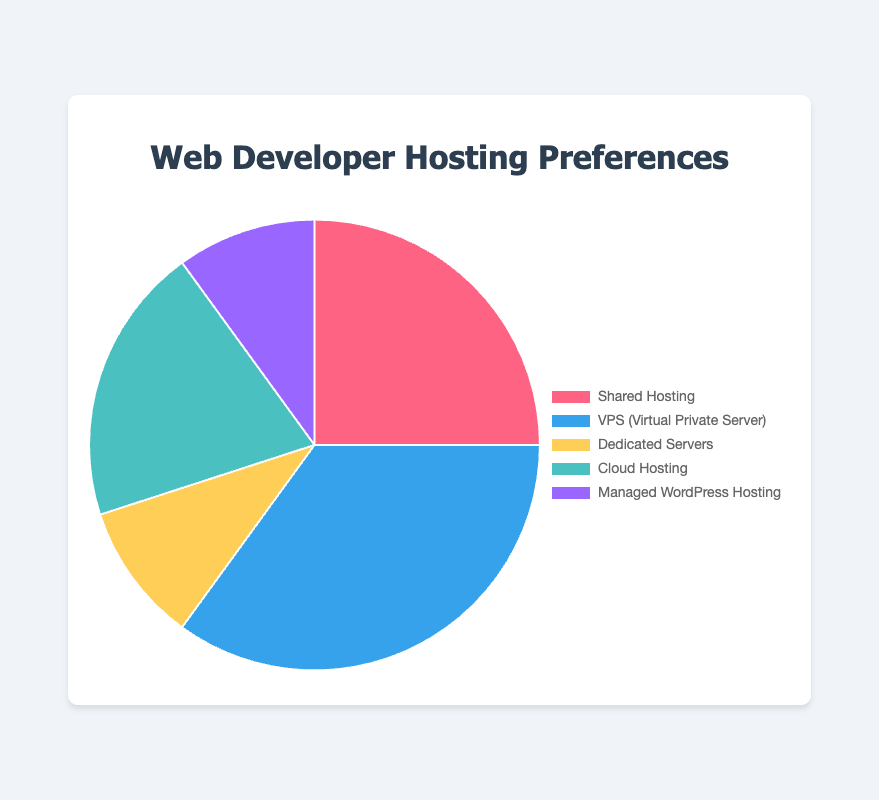Which hosting service has the highest usage percentage among web developers? To find the highest usage percentage, look for the largest percentage value in the data. VPS (Virtual Private Server) has the highest usage percentage at 35%.
Answer: VPS (Virtual Private Server) What is the combined usage percentage of Dedicated Servers and Managed WordPress Hosting? To get the combined usage percentage, add together the percentages of Dedicated Servers (10%) and Managed WordPress Hosting (10%). 10% + 10% = 20%.
Answer: 20% Is the usage percentage of Cloud Hosting higher or lower than Shared Hosting? Compare the usage percentages of Cloud Hosting (20%) and Shared Hosting (25%). Since 20% is less than 25%, Cloud Hosting is lower than Shared Hosting.
Answer: Lower Which hosting types have the same usage percentage? Look for hosting types with equal percentage values in the data. Both Dedicated Servers and Managed WordPress Hosting have a usage percentage of 10%.
Answer: Dedicated Servers and Managed WordPress Hosting What is the total usage percentage of Shared Hosting, VPS, and Cloud Hosting? Sum the usage percentages of Shared Hosting (25%), VPS (35%), and Cloud Hosting (20%). 25% + 35% + 20% = 80%.
Answer: 80% What color represents the hosting service with the lowest usage percentage? Identify the color associated with the hosting service that has the lowest percentage. Both Dedicated Servers and Managed WordPress Hosting have the lowest percentage (10%). Their colors are yellow (Dedicated Servers) and purple (Managed WordPress Hosting).
Answer: Yellow and Purple What is the difference in usage percentage between VPS and Cloud Hosting? Subtract the usage percentage of Cloud Hosting (20%) from VPS (35%). 35% - 20% = 15%.
Answer: 15% Which hosting service is represented by the color blue in the pie chart? Identify the hosting service that corresponds to the color blue. VPS (Virtual Private Server) is represented by blue.
Answer: VPS (Virtual Private Server) How many hosting services have a usage percentage above 20%? Check which hosting services have a usage percentage greater than 20%. Only VPS (35%) and Shared Hosting (25%) are above 20%.
Answer: 2 If Managed WordPress Hosting usage increased by 5%, what would be its new usage percentage? Add 5% to the current percentage of Managed WordPress Hosting (10%). 10% + 5% = 15%.
Answer: 15% 